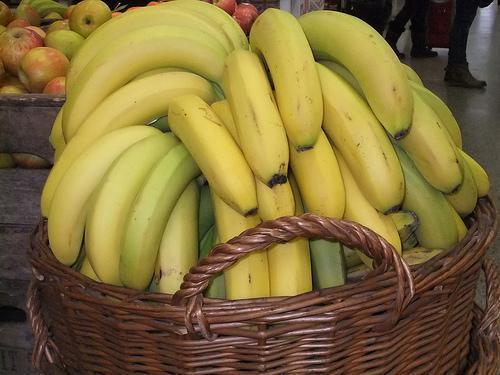How many baskets are in the photo?
Give a very brief answer. 1. 